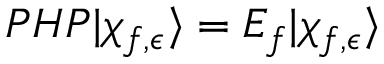<formula> <loc_0><loc_0><loc_500><loc_500>\begin{array} { r } { P H P | \chi _ { f , \epsilon } \rangle = E _ { f } | \chi _ { f , \epsilon } \rangle } \end{array}</formula> 